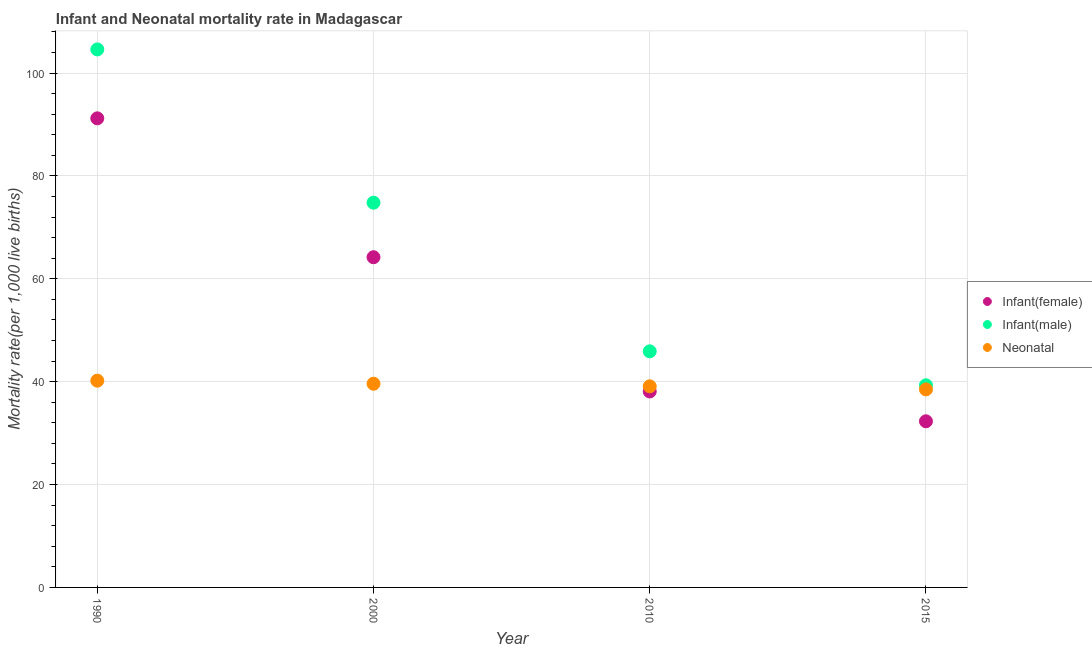How many different coloured dotlines are there?
Your answer should be very brief. 3. What is the infant mortality rate(male) in 2000?
Make the answer very short. 74.8. Across all years, what is the maximum infant mortality rate(female)?
Make the answer very short. 91.2. Across all years, what is the minimum infant mortality rate(female)?
Offer a terse response. 32.3. In which year was the neonatal mortality rate minimum?
Your response must be concise. 2015. What is the total neonatal mortality rate in the graph?
Keep it short and to the point. 157.4. What is the difference between the infant mortality rate(female) in 2000 and that in 2015?
Provide a succinct answer. 31.9. What is the difference between the infant mortality rate(female) in 1990 and the infant mortality rate(male) in 2000?
Your answer should be compact. 16.4. What is the average neonatal mortality rate per year?
Make the answer very short. 39.35. In the year 1990, what is the difference between the neonatal mortality rate and infant mortality rate(female)?
Provide a succinct answer. -51. What is the ratio of the neonatal mortality rate in 1990 to that in 2015?
Your answer should be very brief. 1.04. Is the infant mortality rate(male) in 1990 less than that in 2015?
Offer a very short reply. No. Is the difference between the neonatal mortality rate in 2000 and 2015 greater than the difference between the infant mortality rate(male) in 2000 and 2015?
Offer a terse response. No. What is the difference between the highest and the second highest neonatal mortality rate?
Provide a short and direct response. 0.6. What is the difference between the highest and the lowest infant mortality rate(male)?
Offer a terse response. 65.3. In how many years, is the neonatal mortality rate greater than the average neonatal mortality rate taken over all years?
Keep it short and to the point. 2. How many dotlines are there?
Offer a very short reply. 3. How many years are there in the graph?
Your answer should be compact. 4. Where does the legend appear in the graph?
Ensure brevity in your answer.  Center right. How many legend labels are there?
Give a very brief answer. 3. How are the legend labels stacked?
Offer a very short reply. Vertical. What is the title of the graph?
Offer a very short reply. Infant and Neonatal mortality rate in Madagascar. What is the label or title of the X-axis?
Provide a short and direct response. Year. What is the label or title of the Y-axis?
Provide a succinct answer. Mortality rate(per 1,0 live births). What is the Mortality rate(per 1,000 live births) in Infant(female) in 1990?
Keep it short and to the point. 91.2. What is the Mortality rate(per 1,000 live births) in Infant(male) in 1990?
Offer a very short reply. 104.6. What is the Mortality rate(per 1,000 live births) in Neonatal  in 1990?
Offer a very short reply. 40.2. What is the Mortality rate(per 1,000 live births) of Infant(female) in 2000?
Offer a very short reply. 64.2. What is the Mortality rate(per 1,000 live births) of Infant(male) in 2000?
Offer a terse response. 74.8. What is the Mortality rate(per 1,000 live births) of Neonatal  in 2000?
Your answer should be compact. 39.6. What is the Mortality rate(per 1,000 live births) in Infant(female) in 2010?
Your answer should be very brief. 38.1. What is the Mortality rate(per 1,000 live births) of Infant(male) in 2010?
Offer a terse response. 45.9. What is the Mortality rate(per 1,000 live births) of Neonatal  in 2010?
Offer a very short reply. 39.1. What is the Mortality rate(per 1,000 live births) of Infant(female) in 2015?
Provide a short and direct response. 32.3. What is the Mortality rate(per 1,000 live births) in Infant(male) in 2015?
Keep it short and to the point. 39.3. What is the Mortality rate(per 1,000 live births) in Neonatal  in 2015?
Your answer should be compact. 38.5. Across all years, what is the maximum Mortality rate(per 1,000 live births) of Infant(female)?
Keep it short and to the point. 91.2. Across all years, what is the maximum Mortality rate(per 1,000 live births) of Infant(male)?
Your answer should be very brief. 104.6. Across all years, what is the maximum Mortality rate(per 1,000 live births) in Neonatal ?
Offer a very short reply. 40.2. Across all years, what is the minimum Mortality rate(per 1,000 live births) of Infant(female)?
Your answer should be very brief. 32.3. Across all years, what is the minimum Mortality rate(per 1,000 live births) of Infant(male)?
Ensure brevity in your answer.  39.3. Across all years, what is the minimum Mortality rate(per 1,000 live births) of Neonatal ?
Keep it short and to the point. 38.5. What is the total Mortality rate(per 1,000 live births) of Infant(female) in the graph?
Give a very brief answer. 225.8. What is the total Mortality rate(per 1,000 live births) of Infant(male) in the graph?
Provide a short and direct response. 264.6. What is the total Mortality rate(per 1,000 live births) of Neonatal  in the graph?
Your answer should be very brief. 157.4. What is the difference between the Mortality rate(per 1,000 live births) in Infant(female) in 1990 and that in 2000?
Provide a short and direct response. 27. What is the difference between the Mortality rate(per 1,000 live births) in Infant(male) in 1990 and that in 2000?
Offer a very short reply. 29.8. What is the difference between the Mortality rate(per 1,000 live births) of Neonatal  in 1990 and that in 2000?
Your response must be concise. 0.6. What is the difference between the Mortality rate(per 1,000 live births) of Infant(female) in 1990 and that in 2010?
Provide a succinct answer. 53.1. What is the difference between the Mortality rate(per 1,000 live births) of Infant(male) in 1990 and that in 2010?
Provide a succinct answer. 58.7. What is the difference between the Mortality rate(per 1,000 live births) in Neonatal  in 1990 and that in 2010?
Provide a succinct answer. 1.1. What is the difference between the Mortality rate(per 1,000 live births) of Infant(female) in 1990 and that in 2015?
Offer a terse response. 58.9. What is the difference between the Mortality rate(per 1,000 live births) of Infant(male) in 1990 and that in 2015?
Offer a terse response. 65.3. What is the difference between the Mortality rate(per 1,000 live births) of Infant(female) in 2000 and that in 2010?
Your answer should be very brief. 26.1. What is the difference between the Mortality rate(per 1,000 live births) in Infant(male) in 2000 and that in 2010?
Your response must be concise. 28.9. What is the difference between the Mortality rate(per 1,000 live births) of Infant(female) in 2000 and that in 2015?
Your answer should be compact. 31.9. What is the difference between the Mortality rate(per 1,000 live births) in Infant(male) in 2000 and that in 2015?
Provide a short and direct response. 35.5. What is the difference between the Mortality rate(per 1,000 live births) in Infant(female) in 1990 and the Mortality rate(per 1,000 live births) in Neonatal  in 2000?
Provide a short and direct response. 51.6. What is the difference between the Mortality rate(per 1,000 live births) in Infant(female) in 1990 and the Mortality rate(per 1,000 live births) in Infant(male) in 2010?
Offer a very short reply. 45.3. What is the difference between the Mortality rate(per 1,000 live births) in Infant(female) in 1990 and the Mortality rate(per 1,000 live births) in Neonatal  in 2010?
Provide a short and direct response. 52.1. What is the difference between the Mortality rate(per 1,000 live births) of Infant(male) in 1990 and the Mortality rate(per 1,000 live births) of Neonatal  in 2010?
Provide a short and direct response. 65.5. What is the difference between the Mortality rate(per 1,000 live births) of Infant(female) in 1990 and the Mortality rate(per 1,000 live births) of Infant(male) in 2015?
Give a very brief answer. 51.9. What is the difference between the Mortality rate(per 1,000 live births) in Infant(female) in 1990 and the Mortality rate(per 1,000 live births) in Neonatal  in 2015?
Your answer should be very brief. 52.7. What is the difference between the Mortality rate(per 1,000 live births) of Infant(male) in 1990 and the Mortality rate(per 1,000 live births) of Neonatal  in 2015?
Provide a succinct answer. 66.1. What is the difference between the Mortality rate(per 1,000 live births) in Infant(female) in 2000 and the Mortality rate(per 1,000 live births) in Infant(male) in 2010?
Make the answer very short. 18.3. What is the difference between the Mortality rate(per 1,000 live births) of Infant(female) in 2000 and the Mortality rate(per 1,000 live births) of Neonatal  in 2010?
Provide a succinct answer. 25.1. What is the difference between the Mortality rate(per 1,000 live births) of Infant(male) in 2000 and the Mortality rate(per 1,000 live births) of Neonatal  in 2010?
Ensure brevity in your answer.  35.7. What is the difference between the Mortality rate(per 1,000 live births) of Infant(female) in 2000 and the Mortality rate(per 1,000 live births) of Infant(male) in 2015?
Your answer should be compact. 24.9. What is the difference between the Mortality rate(per 1,000 live births) in Infant(female) in 2000 and the Mortality rate(per 1,000 live births) in Neonatal  in 2015?
Your answer should be very brief. 25.7. What is the difference between the Mortality rate(per 1,000 live births) in Infant(male) in 2000 and the Mortality rate(per 1,000 live births) in Neonatal  in 2015?
Give a very brief answer. 36.3. What is the difference between the Mortality rate(per 1,000 live births) of Infant(female) in 2010 and the Mortality rate(per 1,000 live births) of Infant(male) in 2015?
Give a very brief answer. -1.2. What is the difference between the Mortality rate(per 1,000 live births) in Infant(male) in 2010 and the Mortality rate(per 1,000 live births) in Neonatal  in 2015?
Give a very brief answer. 7.4. What is the average Mortality rate(per 1,000 live births) in Infant(female) per year?
Your answer should be very brief. 56.45. What is the average Mortality rate(per 1,000 live births) of Infant(male) per year?
Provide a succinct answer. 66.15. What is the average Mortality rate(per 1,000 live births) in Neonatal  per year?
Provide a succinct answer. 39.35. In the year 1990, what is the difference between the Mortality rate(per 1,000 live births) in Infant(male) and Mortality rate(per 1,000 live births) in Neonatal ?
Your answer should be compact. 64.4. In the year 2000, what is the difference between the Mortality rate(per 1,000 live births) in Infant(female) and Mortality rate(per 1,000 live births) in Infant(male)?
Your response must be concise. -10.6. In the year 2000, what is the difference between the Mortality rate(per 1,000 live births) of Infant(female) and Mortality rate(per 1,000 live births) of Neonatal ?
Give a very brief answer. 24.6. In the year 2000, what is the difference between the Mortality rate(per 1,000 live births) in Infant(male) and Mortality rate(per 1,000 live births) in Neonatal ?
Offer a very short reply. 35.2. In the year 2015, what is the difference between the Mortality rate(per 1,000 live births) of Infant(female) and Mortality rate(per 1,000 live births) of Neonatal ?
Give a very brief answer. -6.2. What is the ratio of the Mortality rate(per 1,000 live births) of Infant(female) in 1990 to that in 2000?
Give a very brief answer. 1.42. What is the ratio of the Mortality rate(per 1,000 live births) in Infant(male) in 1990 to that in 2000?
Your answer should be very brief. 1.4. What is the ratio of the Mortality rate(per 1,000 live births) of Neonatal  in 1990 to that in 2000?
Provide a succinct answer. 1.02. What is the ratio of the Mortality rate(per 1,000 live births) of Infant(female) in 1990 to that in 2010?
Provide a short and direct response. 2.39. What is the ratio of the Mortality rate(per 1,000 live births) of Infant(male) in 1990 to that in 2010?
Offer a terse response. 2.28. What is the ratio of the Mortality rate(per 1,000 live births) of Neonatal  in 1990 to that in 2010?
Offer a terse response. 1.03. What is the ratio of the Mortality rate(per 1,000 live births) in Infant(female) in 1990 to that in 2015?
Your response must be concise. 2.82. What is the ratio of the Mortality rate(per 1,000 live births) in Infant(male) in 1990 to that in 2015?
Ensure brevity in your answer.  2.66. What is the ratio of the Mortality rate(per 1,000 live births) in Neonatal  in 1990 to that in 2015?
Offer a very short reply. 1.04. What is the ratio of the Mortality rate(per 1,000 live births) in Infant(female) in 2000 to that in 2010?
Your response must be concise. 1.69. What is the ratio of the Mortality rate(per 1,000 live births) in Infant(male) in 2000 to that in 2010?
Offer a very short reply. 1.63. What is the ratio of the Mortality rate(per 1,000 live births) of Neonatal  in 2000 to that in 2010?
Your answer should be very brief. 1.01. What is the ratio of the Mortality rate(per 1,000 live births) in Infant(female) in 2000 to that in 2015?
Your answer should be compact. 1.99. What is the ratio of the Mortality rate(per 1,000 live births) of Infant(male) in 2000 to that in 2015?
Offer a very short reply. 1.9. What is the ratio of the Mortality rate(per 1,000 live births) of Neonatal  in 2000 to that in 2015?
Your response must be concise. 1.03. What is the ratio of the Mortality rate(per 1,000 live births) of Infant(female) in 2010 to that in 2015?
Make the answer very short. 1.18. What is the ratio of the Mortality rate(per 1,000 live births) in Infant(male) in 2010 to that in 2015?
Offer a very short reply. 1.17. What is the ratio of the Mortality rate(per 1,000 live births) in Neonatal  in 2010 to that in 2015?
Provide a succinct answer. 1.02. What is the difference between the highest and the second highest Mortality rate(per 1,000 live births) of Infant(male)?
Ensure brevity in your answer.  29.8. What is the difference between the highest and the second highest Mortality rate(per 1,000 live births) in Neonatal ?
Provide a succinct answer. 0.6. What is the difference between the highest and the lowest Mortality rate(per 1,000 live births) of Infant(female)?
Offer a terse response. 58.9. What is the difference between the highest and the lowest Mortality rate(per 1,000 live births) of Infant(male)?
Offer a very short reply. 65.3. 